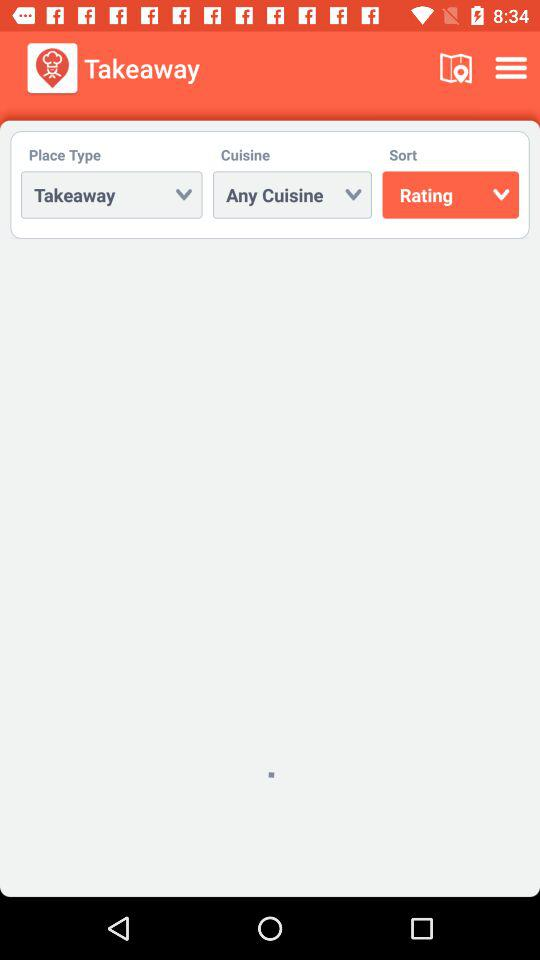What is the app name? The app name is "Restaurant Finder". 